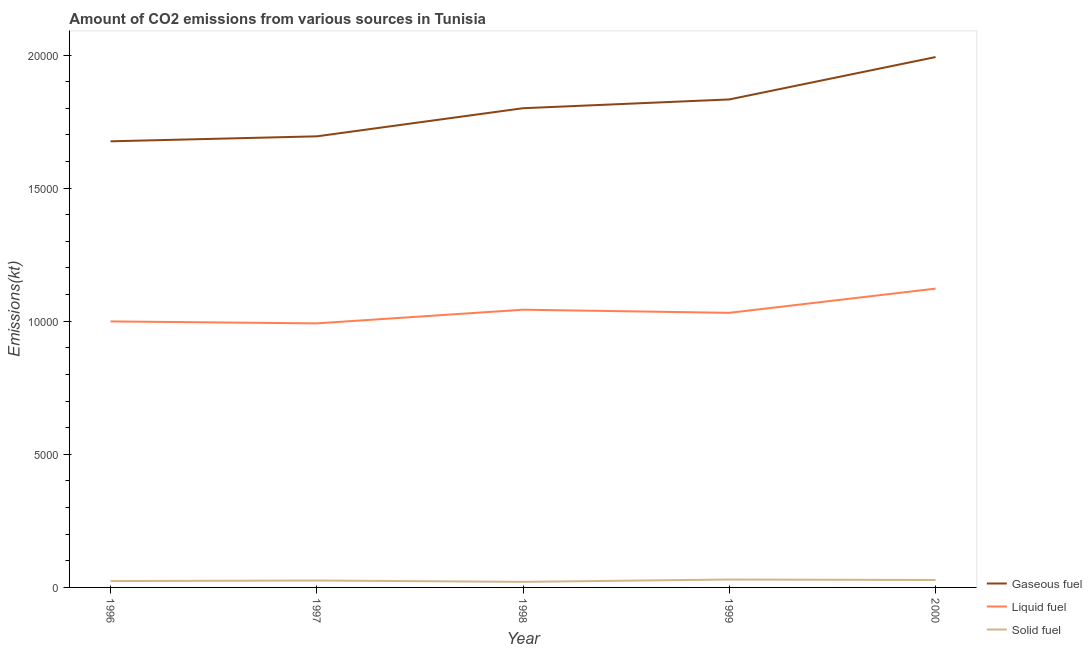How many different coloured lines are there?
Provide a short and direct response. 3. Does the line corresponding to amount of co2 emissions from gaseous fuel intersect with the line corresponding to amount of co2 emissions from liquid fuel?
Your answer should be very brief. No. Is the number of lines equal to the number of legend labels?
Make the answer very short. Yes. What is the amount of co2 emissions from solid fuel in 1999?
Your answer should be very brief. 297.03. Across all years, what is the maximum amount of co2 emissions from gaseous fuel?
Make the answer very short. 1.99e+04. Across all years, what is the minimum amount of co2 emissions from liquid fuel?
Give a very brief answer. 9919.24. What is the total amount of co2 emissions from liquid fuel in the graph?
Provide a short and direct response. 5.19e+04. What is the difference between the amount of co2 emissions from gaseous fuel in 1996 and that in 2000?
Offer a terse response. -3164.62. What is the difference between the amount of co2 emissions from gaseous fuel in 1997 and the amount of co2 emissions from liquid fuel in 1999?
Offer a very short reply. 6629.94. What is the average amount of co2 emissions from liquid fuel per year?
Your response must be concise. 1.04e+04. In the year 2000, what is the difference between the amount of co2 emissions from solid fuel and amount of co2 emissions from liquid fuel?
Ensure brevity in your answer.  -1.09e+04. What is the ratio of the amount of co2 emissions from liquid fuel in 1997 to that in 2000?
Keep it short and to the point. 0.88. Is the amount of co2 emissions from gaseous fuel in 1997 less than that in 1998?
Your answer should be compact. Yes. Is the difference between the amount of co2 emissions from solid fuel in 1997 and 1998 greater than the difference between the amount of co2 emissions from gaseous fuel in 1997 and 1998?
Keep it short and to the point. Yes. What is the difference between the highest and the second highest amount of co2 emissions from gaseous fuel?
Give a very brief answer. 1591.48. What is the difference between the highest and the lowest amount of co2 emissions from liquid fuel?
Give a very brief answer. 1305.45. Does the amount of co2 emissions from gaseous fuel monotonically increase over the years?
Your answer should be very brief. Yes. Is the amount of co2 emissions from gaseous fuel strictly greater than the amount of co2 emissions from liquid fuel over the years?
Your answer should be compact. Yes. How many lines are there?
Your answer should be very brief. 3. What is the difference between two consecutive major ticks on the Y-axis?
Offer a terse response. 5000. Does the graph contain grids?
Provide a succinct answer. No. Where does the legend appear in the graph?
Your answer should be very brief. Bottom right. How many legend labels are there?
Offer a terse response. 3. How are the legend labels stacked?
Provide a succinct answer. Vertical. What is the title of the graph?
Provide a succinct answer. Amount of CO2 emissions from various sources in Tunisia. What is the label or title of the Y-axis?
Provide a succinct answer. Emissions(kt). What is the Emissions(kt) in Gaseous fuel in 1996?
Provide a succinct answer. 1.68e+04. What is the Emissions(kt) in Liquid fuel in 1996?
Your answer should be compact. 9992.58. What is the Emissions(kt) of Solid fuel in 1996?
Make the answer very short. 238.35. What is the Emissions(kt) in Gaseous fuel in 1997?
Provide a short and direct response. 1.69e+04. What is the Emissions(kt) in Liquid fuel in 1997?
Provide a short and direct response. 9919.24. What is the Emissions(kt) in Solid fuel in 1997?
Provide a succinct answer. 260.36. What is the Emissions(kt) of Gaseous fuel in 1998?
Your response must be concise. 1.80e+04. What is the Emissions(kt) of Liquid fuel in 1998?
Provide a succinct answer. 1.04e+04. What is the Emissions(kt) of Solid fuel in 1998?
Keep it short and to the point. 209.02. What is the Emissions(kt) in Gaseous fuel in 1999?
Your response must be concise. 1.83e+04. What is the Emissions(kt) in Liquid fuel in 1999?
Give a very brief answer. 1.03e+04. What is the Emissions(kt) of Solid fuel in 1999?
Your answer should be compact. 297.03. What is the Emissions(kt) of Gaseous fuel in 2000?
Give a very brief answer. 1.99e+04. What is the Emissions(kt) of Liquid fuel in 2000?
Offer a very short reply. 1.12e+04. What is the Emissions(kt) in Solid fuel in 2000?
Provide a short and direct response. 278.69. Across all years, what is the maximum Emissions(kt) in Gaseous fuel?
Ensure brevity in your answer.  1.99e+04. Across all years, what is the maximum Emissions(kt) in Liquid fuel?
Your response must be concise. 1.12e+04. Across all years, what is the maximum Emissions(kt) of Solid fuel?
Make the answer very short. 297.03. Across all years, what is the minimum Emissions(kt) of Gaseous fuel?
Your answer should be compact. 1.68e+04. Across all years, what is the minimum Emissions(kt) in Liquid fuel?
Make the answer very short. 9919.24. Across all years, what is the minimum Emissions(kt) of Solid fuel?
Make the answer very short. 209.02. What is the total Emissions(kt) in Gaseous fuel in the graph?
Ensure brevity in your answer.  9.00e+04. What is the total Emissions(kt) of Liquid fuel in the graph?
Ensure brevity in your answer.  5.19e+04. What is the total Emissions(kt) of Solid fuel in the graph?
Your answer should be compact. 1283.45. What is the difference between the Emissions(kt) in Gaseous fuel in 1996 and that in 1997?
Your answer should be compact. -187.02. What is the difference between the Emissions(kt) of Liquid fuel in 1996 and that in 1997?
Offer a terse response. 73.34. What is the difference between the Emissions(kt) in Solid fuel in 1996 and that in 1997?
Your response must be concise. -22. What is the difference between the Emissions(kt) in Gaseous fuel in 1996 and that in 1998?
Make the answer very short. -1243.11. What is the difference between the Emissions(kt) of Liquid fuel in 1996 and that in 1998?
Provide a succinct answer. -440.04. What is the difference between the Emissions(kt) of Solid fuel in 1996 and that in 1998?
Provide a short and direct response. 29.34. What is the difference between the Emissions(kt) in Gaseous fuel in 1996 and that in 1999?
Keep it short and to the point. -1573.14. What is the difference between the Emissions(kt) in Liquid fuel in 1996 and that in 1999?
Your answer should be very brief. -322.7. What is the difference between the Emissions(kt) in Solid fuel in 1996 and that in 1999?
Give a very brief answer. -58.67. What is the difference between the Emissions(kt) of Gaseous fuel in 1996 and that in 2000?
Ensure brevity in your answer.  -3164.62. What is the difference between the Emissions(kt) of Liquid fuel in 1996 and that in 2000?
Your answer should be compact. -1232.11. What is the difference between the Emissions(kt) of Solid fuel in 1996 and that in 2000?
Provide a short and direct response. -40.34. What is the difference between the Emissions(kt) of Gaseous fuel in 1997 and that in 1998?
Provide a short and direct response. -1056.1. What is the difference between the Emissions(kt) of Liquid fuel in 1997 and that in 1998?
Give a very brief answer. -513.38. What is the difference between the Emissions(kt) in Solid fuel in 1997 and that in 1998?
Provide a succinct answer. 51.34. What is the difference between the Emissions(kt) of Gaseous fuel in 1997 and that in 1999?
Provide a short and direct response. -1386.13. What is the difference between the Emissions(kt) of Liquid fuel in 1997 and that in 1999?
Your answer should be very brief. -396.04. What is the difference between the Emissions(kt) in Solid fuel in 1997 and that in 1999?
Provide a short and direct response. -36.67. What is the difference between the Emissions(kt) of Gaseous fuel in 1997 and that in 2000?
Ensure brevity in your answer.  -2977.6. What is the difference between the Emissions(kt) in Liquid fuel in 1997 and that in 2000?
Make the answer very short. -1305.45. What is the difference between the Emissions(kt) of Solid fuel in 1997 and that in 2000?
Your answer should be very brief. -18.34. What is the difference between the Emissions(kt) in Gaseous fuel in 1998 and that in 1999?
Make the answer very short. -330.03. What is the difference between the Emissions(kt) in Liquid fuel in 1998 and that in 1999?
Your answer should be compact. 117.34. What is the difference between the Emissions(kt) of Solid fuel in 1998 and that in 1999?
Give a very brief answer. -88.01. What is the difference between the Emissions(kt) in Gaseous fuel in 1998 and that in 2000?
Offer a very short reply. -1921.51. What is the difference between the Emissions(kt) in Liquid fuel in 1998 and that in 2000?
Provide a succinct answer. -792.07. What is the difference between the Emissions(kt) of Solid fuel in 1998 and that in 2000?
Offer a terse response. -69.67. What is the difference between the Emissions(kt) of Gaseous fuel in 1999 and that in 2000?
Your answer should be compact. -1591.48. What is the difference between the Emissions(kt) in Liquid fuel in 1999 and that in 2000?
Your answer should be very brief. -909.42. What is the difference between the Emissions(kt) in Solid fuel in 1999 and that in 2000?
Offer a terse response. 18.34. What is the difference between the Emissions(kt) in Gaseous fuel in 1996 and the Emissions(kt) in Liquid fuel in 1997?
Offer a very short reply. 6838.95. What is the difference between the Emissions(kt) in Gaseous fuel in 1996 and the Emissions(kt) in Solid fuel in 1997?
Give a very brief answer. 1.65e+04. What is the difference between the Emissions(kt) of Liquid fuel in 1996 and the Emissions(kt) of Solid fuel in 1997?
Provide a succinct answer. 9732.22. What is the difference between the Emissions(kt) in Gaseous fuel in 1996 and the Emissions(kt) in Liquid fuel in 1998?
Keep it short and to the point. 6325.57. What is the difference between the Emissions(kt) in Gaseous fuel in 1996 and the Emissions(kt) in Solid fuel in 1998?
Make the answer very short. 1.65e+04. What is the difference between the Emissions(kt) in Liquid fuel in 1996 and the Emissions(kt) in Solid fuel in 1998?
Keep it short and to the point. 9783.56. What is the difference between the Emissions(kt) of Gaseous fuel in 1996 and the Emissions(kt) of Liquid fuel in 1999?
Keep it short and to the point. 6442.92. What is the difference between the Emissions(kt) in Gaseous fuel in 1996 and the Emissions(kt) in Solid fuel in 1999?
Give a very brief answer. 1.65e+04. What is the difference between the Emissions(kt) in Liquid fuel in 1996 and the Emissions(kt) in Solid fuel in 1999?
Provide a succinct answer. 9695.55. What is the difference between the Emissions(kt) of Gaseous fuel in 1996 and the Emissions(kt) of Liquid fuel in 2000?
Make the answer very short. 5533.5. What is the difference between the Emissions(kt) in Gaseous fuel in 1996 and the Emissions(kt) in Solid fuel in 2000?
Ensure brevity in your answer.  1.65e+04. What is the difference between the Emissions(kt) in Liquid fuel in 1996 and the Emissions(kt) in Solid fuel in 2000?
Provide a short and direct response. 9713.88. What is the difference between the Emissions(kt) of Gaseous fuel in 1997 and the Emissions(kt) of Liquid fuel in 1998?
Offer a very short reply. 6512.59. What is the difference between the Emissions(kt) in Gaseous fuel in 1997 and the Emissions(kt) in Solid fuel in 1998?
Ensure brevity in your answer.  1.67e+04. What is the difference between the Emissions(kt) in Liquid fuel in 1997 and the Emissions(kt) in Solid fuel in 1998?
Make the answer very short. 9710.22. What is the difference between the Emissions(kt) in Gaseous fuel in 1997 and the Emissions(kt) in Liquid fuel in 1999?
Ensure brevity in your answer.  6629.94. What is the difference between the Emissions(kt) of Gaseous fuel in 1997 and the Emissions(kt) of Solid fuel in 1999?
Provide a succinct answer. 1.66e+04. What is the difference between the Emissions(kt) in Liquid fuel in 1997 and the Emissions(kt) in Solid fuel in 1999?
Make the answer very short. 9622.21. What is the difference between the Emissions(kt) of Gaseous fuel in 1997 and the Emissions(kt) of Liquid fuel in 2000?
Your answer should be compact. 5720.52. What is the difference between the Emissions(kt) in Gaseous fuel in 1997 and the Emissions(kt) in Solid fuel in 2000?
Your answer should be very brief. 1.67e+04. What is the difference between the Emissions(kt) in Liquid fuel in 1997 and the Emissions(kt) in Solid fuel in 2000?
Offer a very short reply. 9640.54. What is the difference between the Emissions(kt) of Gaseous fuel in 1998 and the Emissions(kt) of Liquid fuel in 1999?
Your answer should be very brief. 7686.03. What is the difference between the Emissions(kt) in Gaseous fuel in 1998 and the Emissions(kt) in Solid fuel in 1999?
Your answer should be very brief. 1.77e+04. What is the difference between the Emissions(kt) in Liquid fuel in 1998 and the Emissions(kt) in Solid fuel in 1999?
Give a very brief answer. 1.01e+04. What is the difference between the Emissions(kt) of Gaseous fuel in 1998 and the Emissions(kt) of Liquid fuel in 2000?
Make the answer very short. 6776.62. What is the difference between the Emissions(kt) in Gaseous fuel in 1998 and the Emissions(kt) in Solid fuel in 2000?
Provide a short and direct response. 1.77e+04. What is the difference between the Emissions(kt) in Liquid fuel in 1998 and the Emissions(kt) in Solid fuel in 2000?
Offer a very short reply. 1.02e+04. What is the difference between the Emissions(kt) in Gaseous fuel in 1999 and the Emissions(kt) in Liquid fuel in 2000?
Your response must be concise. 7106.65. What is the difference between the Emissions(kt) in Gaseous fuel in 1999 and the Emissions(kt) in Solid fuel in 2000?
Make the answer very short. 1.81e+04. What is the difference between the Emissions(kt) of Liquid fuel in 1999 and the Emissions(kt) of Solid fuel in 2000?
Ensure brevity in your answer.  1.00e+04. What is the average Emissions(kt) of Gaseous fuel per year?
Keep it short and to the point. 1.80e+04. What is the average Emissions(kt) of Liquid fuel per year?
Keep it short and to the point. 1.04e+04. What is the average Emissions(kt) in Solid fuel per year?
Provide a short and direct response. 256.69. In the year 1996, what is the difference between the Emissions(kt) in Gaseous fuel and Emissions(kt) in Liquid fuel?
Provide a short and direct response. 6765.61. In the year 1996, what is the difference between the Emissions(kt) in Gaseous fuel and Emissions(kt) in Solid fuel?
Give a very brief answer. 1.65e+04. In the year 1996, what is the difference between the Emissions(kt) of Liquid fuel and Emissions(kt) of Solid fuel?
Provide a short and direct response. 9754.22. In the year 1997, what is the difference between the Emissions(kt) in Gaseous fuel and Emissions(kt) in Liquid fuel?
Provide a short and direct response. 7025.97. In the year 1997, what is the difference between the Emissions(kt) of Gaseous fuel and Emissions(kt) of Solid fuel?
Make the answer very short. 1.67e+04. In the year 1997, what is the difference between the Emissions(kt) of Liquid fuel and Emissions(kt) of Solid fuel?
Offer a very short reply. 9658.88. In the year 1998, what is the difference between the Emissions(kt) of Gaseous fuel and Emissions(kt) of Liquid fuel?
Your answer should be very brief. 7568.69. In the year 1998, what is the difference between the Emissions(kt) of Gaseous fuel and Emissions(kt) of Solid fuel?
Provide a succinct answer. 1.78e+04. In the year 1998, what is the difference between the Emissions(kt) of Liquid fuel and Emissions(kt) of Solid fuel?
Provide a short and direct response. 1.02e+04. In the year 1999, what is the difference between the Emissions(kt) in Gaseous fuel and Emissions(kt) in Liquid fuel?
Your answer should be compact. 8016.06. In the year 1999, what is the difference between the Emissions(kt) of Gaseous fuel and Emissions(kt) of Solid fuel?
Your response must be concise. 1.80e+04. In the year 1999, what is the difference between the Emissions(kt) of Liquid fuel and Emissions(kt) of Solid fuel?
Provide a succinct answer. 1.00e+04. In the year 2000, what is the difference between the Emissions(kt) of Gaseous fuel and Emissions(kt) of Liquid fuel?
Offer a terse response. 8698.12. In the year 2000, what is the difference between the Emissions(kt) in Gaseous fuel and Emissions(kt) in Solid fuel?
Offer a very short reply. 1.96e+04. In the year 2000, what is the difference between the Emissions(kt) of Liquid fuel and Emissions(kt) of Solid fuel?
Offer a very short reply. 1.09e+04. What is the ratio of the Emissions(kt) of Gaseous fuel in 1996 to that in 1997?
Provide a short and direct response. 0.99. What is the ratio of the Emissions(kt) in Liquid fuel in 1996 to that in 1997?
Your response must be concise. 1.01. What is the ratio of the Emissions(kt) of Solid fuel in 1996 to that in 1997?
Your response must be concise. 0.92. What is the ratio of the Emissions(kt) in Gaseous fuel in 1996 to that in 1998?
Make the answer very short. 0.93. What is the ratio of the Emissions(kt) of Liquid fuel in 1996 to that in 1998?
Your answer should be compact. 0.96. What is the ratio of the Emissions(kt) of Solid fuel in 1996 to that in 1998?
Keep it short and to the point. 1.14. What is the ratio of the Emissions(kt) of Gaseous fuel in 1996 to that in 1999?
Give a very brief answer. 0.91. What is the ratio of the Emissions(kt) of Liquid fuel in 1996 to that in 1999?
Provide a short and direct response. 0.97. What is the ratio of the Emissions(kt) of Solid fuel in 1996 to that in 1999?
Give a very brief answer. 0.8. What is the ratio of the Emissions(kt) of Gaseous fuel in 1996 to that in 2000?
Give a very brief answer. 0.84. What is the ratio of the Emissions(kt) of Liquid fuel in 1996 to that in 2000?
Your answer should be very brief. 0.89. What is the ratio of the Emissions(kt) in Solid fuel in 1996 to that in 2000?
Your answer should be compact. 0.86. What is the ratio of the Emissions(kt) in Gaseous fuel in 1997 to that in 1998?
Keep it short and to the point. 0.94. What is the ratio of the Emissions(kt) of Liquid fuel in 1997 to that in 1998?
Make the answer very short. 0.95. What is the ratio of the Emissions(kt) in Solid fuel in 1997 to that in 1998?
Make the answer very short. 1.25. What is the ratio of the Emissions(kt) in Gaseous fuel in 1997 to that in 1999?
Keep it short and to the point. 0.92. What is the ratio of the Emissions(kt) in Liquid fuel in 1997 to that in 1999?
Keep it short and to the point. 0.96. What is the ratio of the Emissions(kt) of Solid fuel in 1997 to that in 1999?
Provide a short and direct response. 0.88. What is the ratio of the Emissions(kt) of Gaseous fuel in 1997 to that in 2000?
Your response must be concise. 0.85. What is the ratio of the Emissions(kt) of Liquid fuel in 1997 to that in 2000?
Offer a terse response. 0.88. What is the ratio of the Emissions(kt) in Solid fuel in 1997 to that in 2000?
Offer a terse response. 0.93. What is the ratio of the Emissions(kt) of Gaseous fuel in 1998 to that in 1999?
Offer a very short reply. 0.98. What is the ratio of the Emissions(kt) in Liquid fuel in 1998 to that in 1999?
Offer a very short reply. 1.01. What is the ratio of the Emissions(kt) in Solid fuel in 1998 to that in 1999?
Offer a terse response. 0.7. What is the ratio of the Emissions(kt) of Gaseous fuel in 1998 to that in 2000?
Your answer should be compact. 0.9. What is the ratio of the Emissions(kt) of Liquid fuel in 1998 to that in 2000?
Offer a terse response. 0.93. What is the ratio of the Emissions(kt) of Solid fuel in 1998 to that in 2000?
Your answer should be very brief. 0.75. What is the ratio of the Emissions(kt) of Gaseous fuel in 1999 to that in 2000?
Provide a short and direct response. 0.92. What is the ratio of the Emissions(kt) in Liquid fuel in 1999 to that in 2000?
Your response must be concise. 0.92. What is the ratio of the Emissions(kt) of Solid fuel in 1999 to that in 2000?
Make the answer very short. 1.07. What is the difference between the highest and the second highest Emissions(kt) in Gaseous fuel?
Provide a succinct answer. 1591.48. What is the difference between the highest and the second highest Emissions(kt) in Liquid fuel?
Ensure brevity in your answer.  792.07. What is the difference between the highest and the second highest Emissions(kt) in Solid fuel?
Offer a very short reply. 18.34. What is the difference between the highest and the lowest Emissions(kt) of Gaseous fuel?
Offer a very short reply. 3164.62. What is the difference between the highest and the lowest Emissions(kt) in Liquid fuel?
Provide a short and direct response. 1305.45. What is the difference between the highest and the lowest Emissions(kt) in Solid fuel?
Make the answer very short. 88.01. 